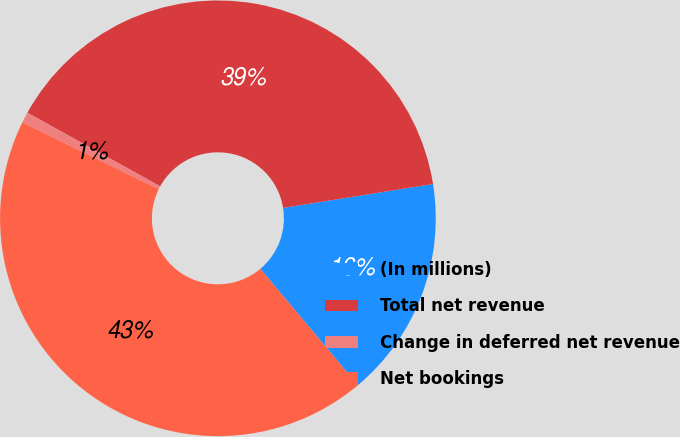Convert chart. <chart><loc_0><loc_0><loc_500><loc_500><pie_chart><fcel>(In millions)<fcel>Total net revenue<fcel>Change in deferred net revenue<fcel>Net bookings<nl><fcel>16.41%<fcel>39.43%<fcel>0.79%<fcel>43.37%<nl></chart> 